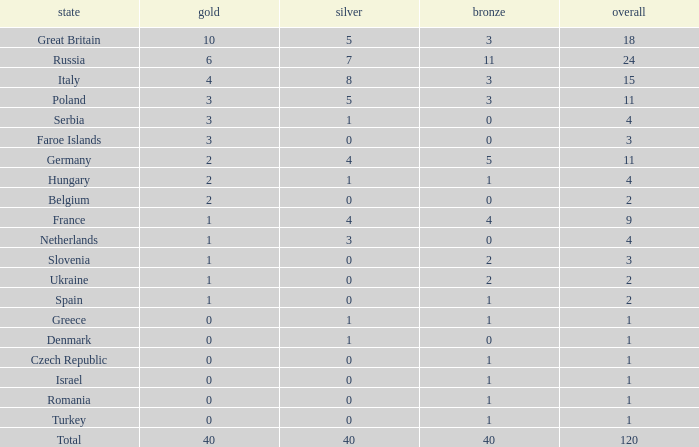What is turkey's typical gold entry with a bronze entry smaller than 2 and a total larger than 1? None. 